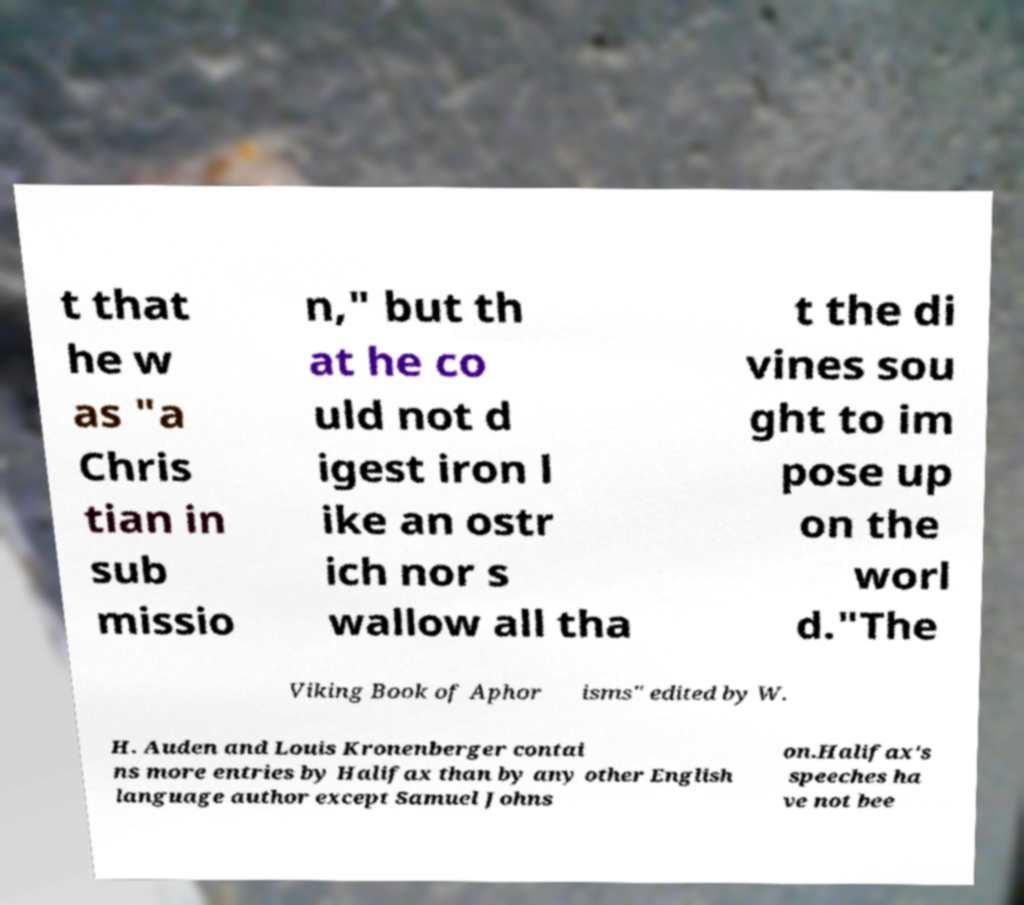For documentation purposes, I need the text within this image transcribed. Could you provide that? t that he w as "a Chris tian in sub missio n," but th at he co uld not d igest iron l ike an ostr ich nor s wallow all tha t the di vines sou ght to im pose up on the worl d."The Viking Book of Aphor isms" edited by W. H. Auden and Louis Kronenberger contai ns more entries by Halifax than by any other English language author except Samuel Johns on.Halifax's speeches ha ve not bee 